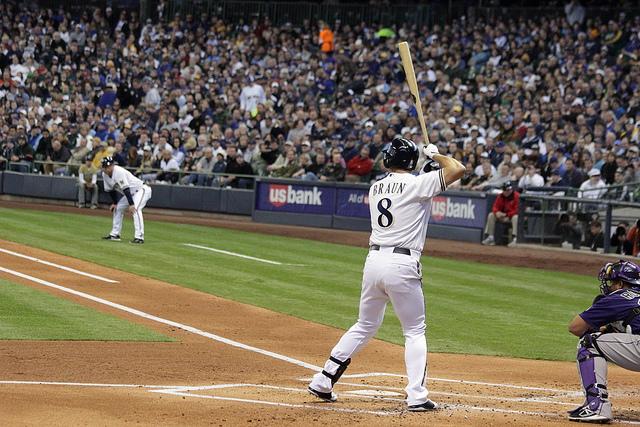What number is on the batter's jersey?
Short answer required. 8. What number is the guy in the white?
Answer briefly. 8. What game is being played?
Answer briefly. Baseball. Why are there so many people sitting in seats behind the players?
Concise answer only. Watching game. 